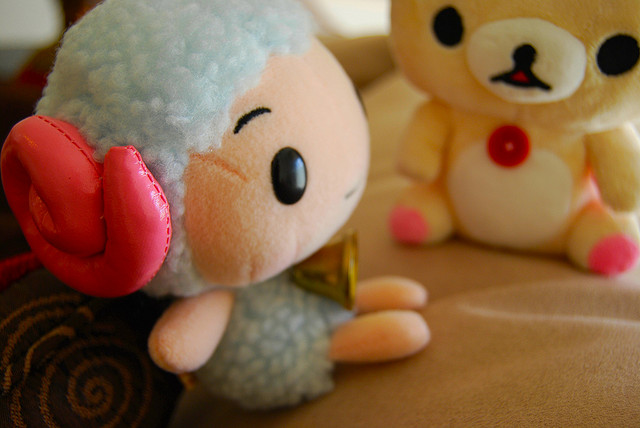<image>What do you see on the oranges that might bring a smile to a human's face? I don't know what might bring a smile to a human's face on the oranges. There could be a sticker, a plushie, or a stuffed animal on them. What do you see on the oranges that might bring a smile to a human's face? I am not sure what you see on the oranges that might bring a smile to a human's face. However, it can be seen a plushie, a sticker, or stuffed animals. 